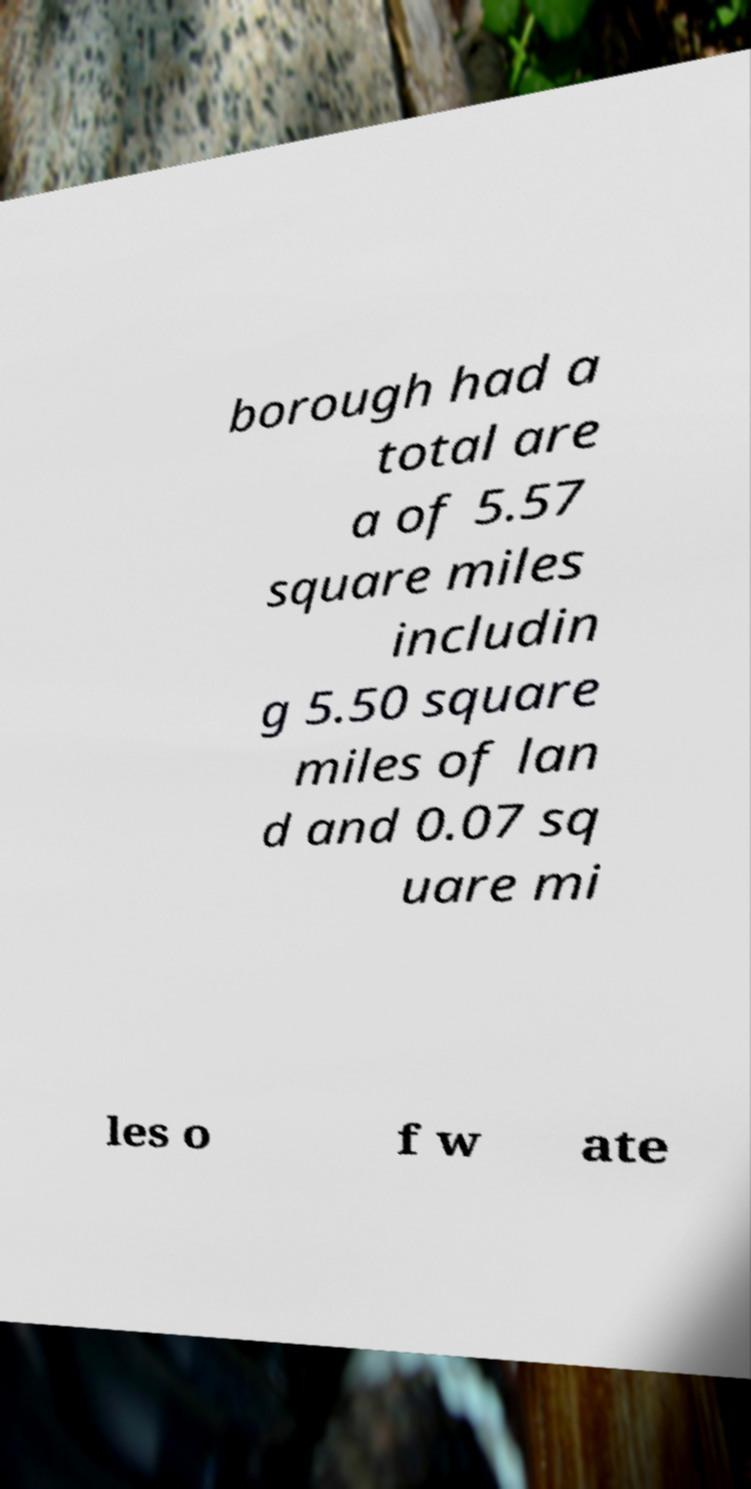What messages or text are displayed in this image? I need them in a readable, typed format. borough had a total are a of 5.57 square miles includin g 5.50 square miles of lan d and 0.07 sq uare mi les o f w ate 